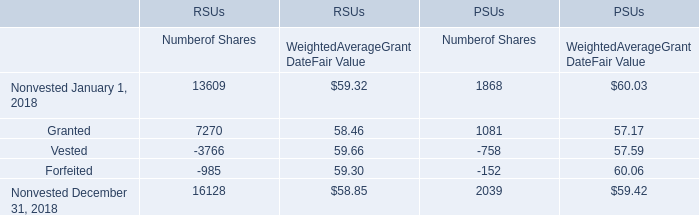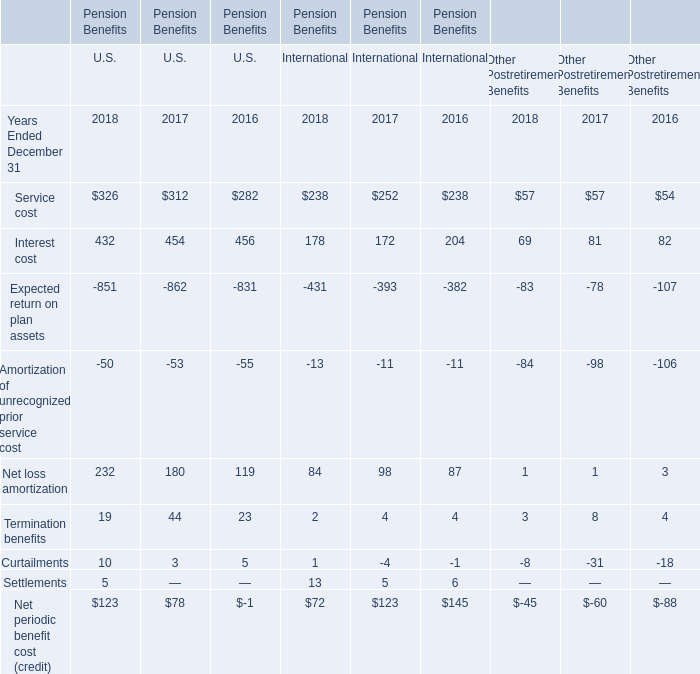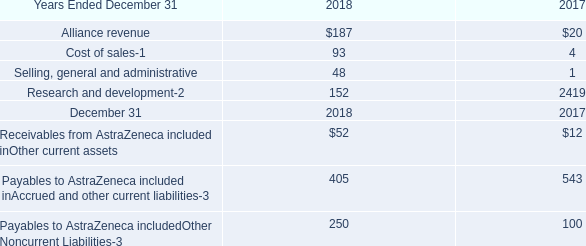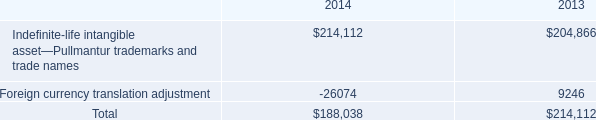What was the total amount of the Net loss amortization in the years where Settlements greater than 0? 
Computations: ((((((((232 + 180) + 119) + 84) + 98) + 87) + 1) + 1) + 3)
Answer: 805.0. 